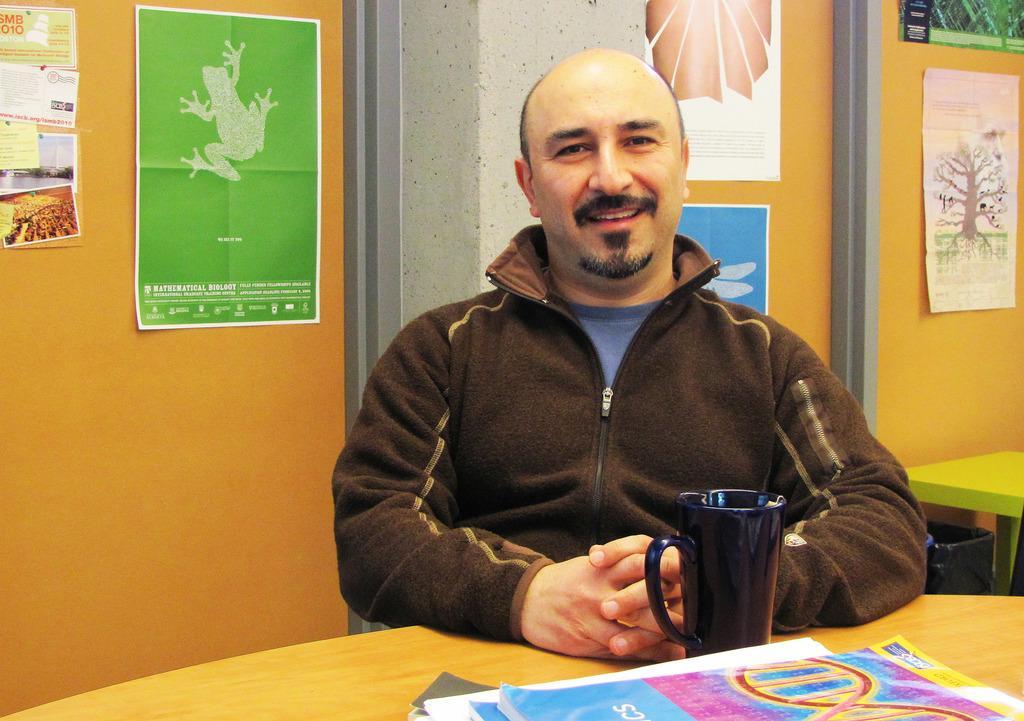How would you summarize this image in a sentence or two? This might be a picture taken in a classroom. In the foreground of the picture there is a table, on the table there are books and a cup. In the center of the picture there is a person sitting and smiling. On the left, on the wall there are posters attached. On the the top right and center there are posters attached. 